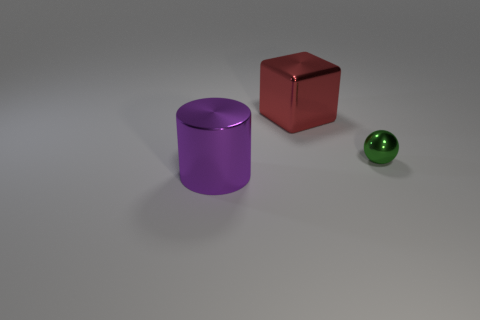What color is the object that is in front of the tiny shiny sphere? purple 